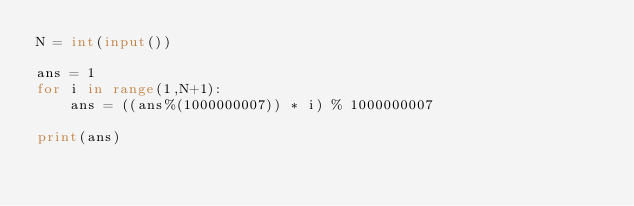<code> <loc_0><loc_0><loc_500><loc_500><_Python_>N = int(input())

ans = 1
for i in range(1,N+1):
    ans = ((ans%(1000000007)) * i) % 1000000007

print(ans)</code> 